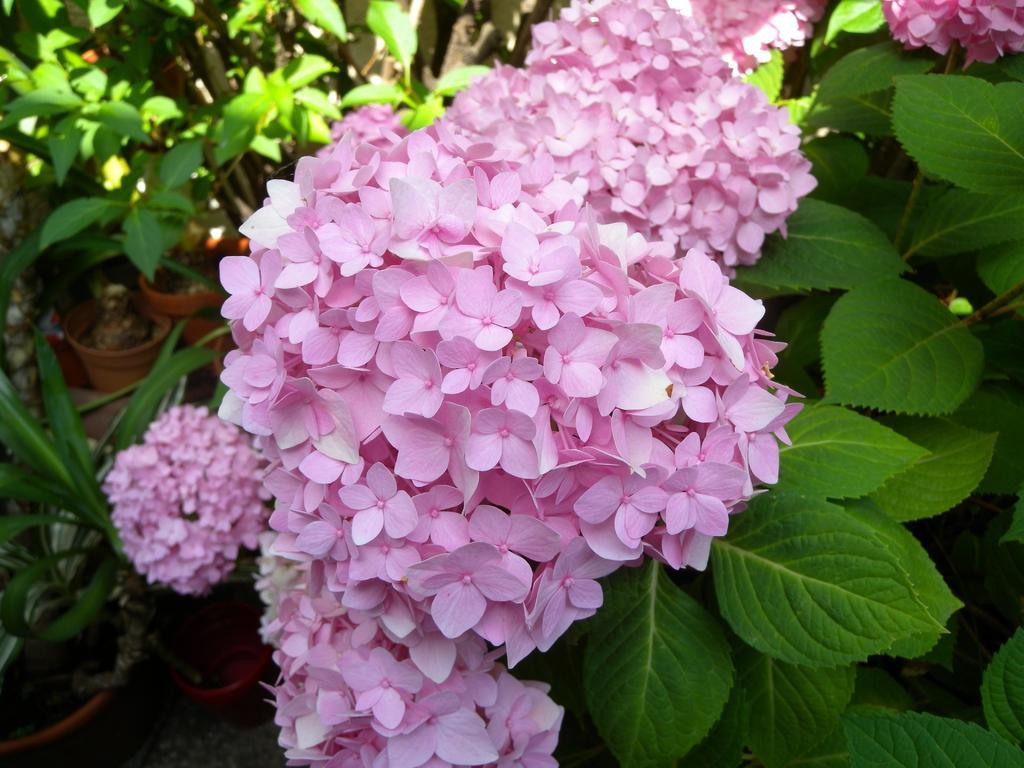Please provide a concise description of this image. In this image I can see pink color flowers. Here I can see number of flower vases. 